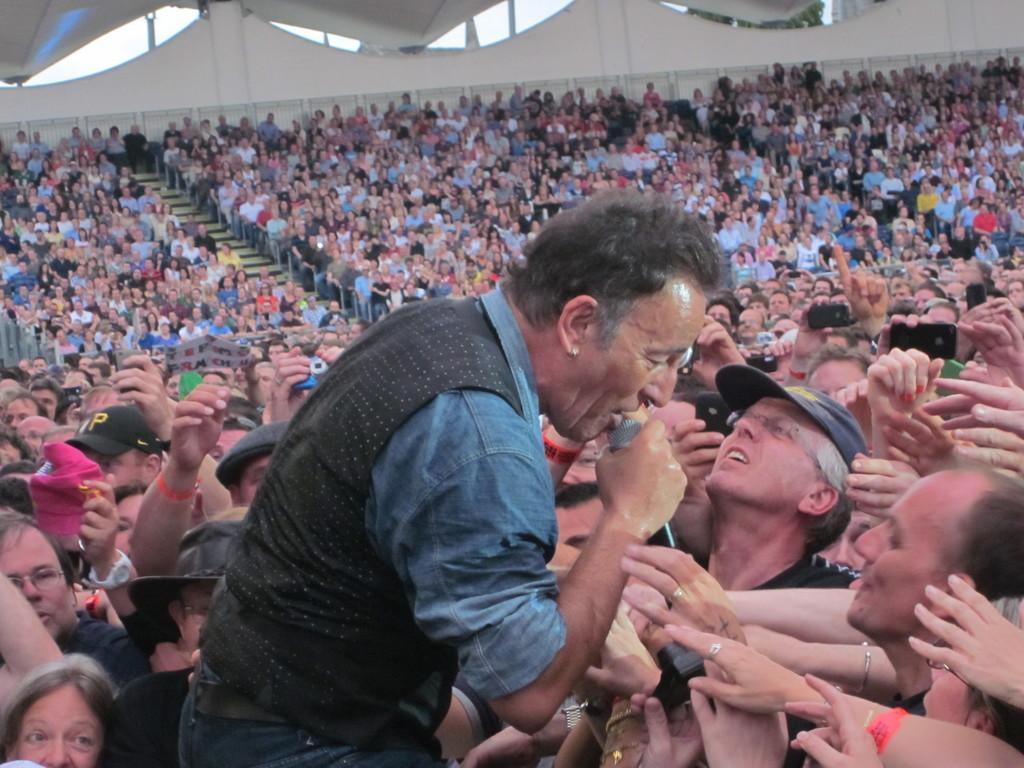Please provide a concise description of this image. In this image we can see some people. And we can see some people sitting in chairs. And some are standing. And we can see a microphone in one person's hand. And we can see the metal fence, hall. And we can see the wall, stairs. 